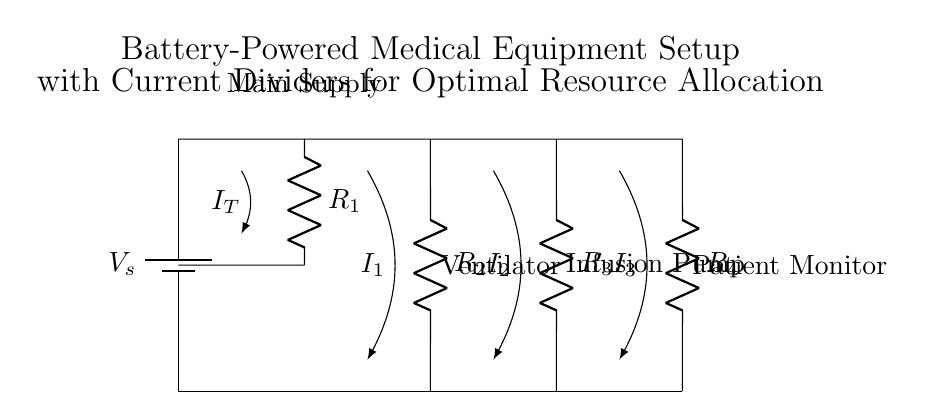What is the total current entering the circuit? The total current is represented by \( I_T \) and is the current entering the main supply before it splits into the parallel branches.
Answer: \( I_T \) What is the function of the resistors in the circuit? The resistors \( R_1 \), \( R_2 \), \( R_3 \), and \( R_4 \) control the distribution of current to each parallel branch, affecting how much current each device receives based on their resistance values.
Answer: Current distribution What devices are powered by this setup? The circuit powers a ventilator, an infusion pump, and a patient monitor, each connected in parallel to the supply voltage.
Answer: Ventilator, infusion pump, patient monitor Which resistor is associated with the ventilator? The resistor associated with the ventilator is \( R_2 \) as it is directly connected to the branch leading to the ventilator.
Answer: \( R_2 \) How does current division occur in this circuit? Current division occurs as the total current \( I_T \) splits into the branches, where the current through each resistor is inversely proportional to its resistance value, following the current divider rule.
Answer: Inversely proportional to resistance What happens to the total voltage across each parallel branch? The total voltage across each parallel branch remains the same as the supply voltage \( V_s \) since all branches are connected to the same two points of the circuit.
Answer: Equal to \( V_s \) How does the current through \( R_3 \) compare to that through \( R_4 \)? The current through \( R_3 \) (infusion pump) and \( R_4 \) (patient monitor) will be different and depend on their respective resistance values, affecting how much current each device receives.
Answer: Different currents 